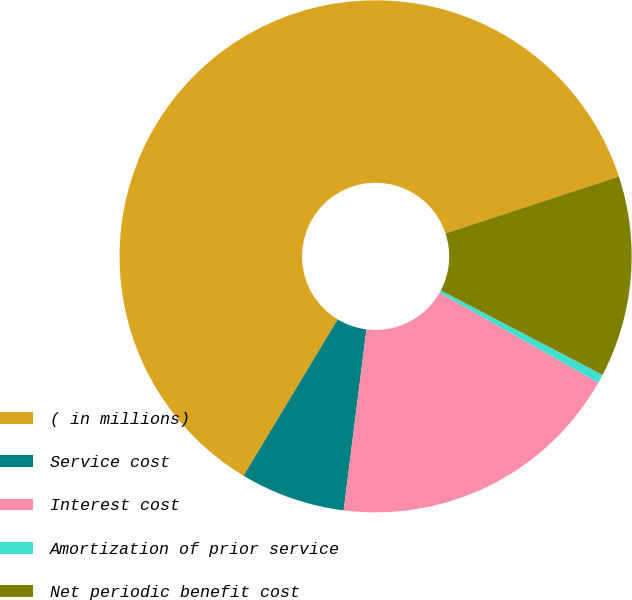Convert chart. <chart><loc_0><loc_0><loc_500><loc_500><pie_chart><fcel>( in millions)<fcel>Service cost<fcel>Interest cost<fcel>Amortization of prior service<fcel>Net periodic benefit cost<nl><fcel>61.33%<fcel>6.63%<fcel>18.78%<fcel>0.55%<fcel>12.71%<nl></chart> 